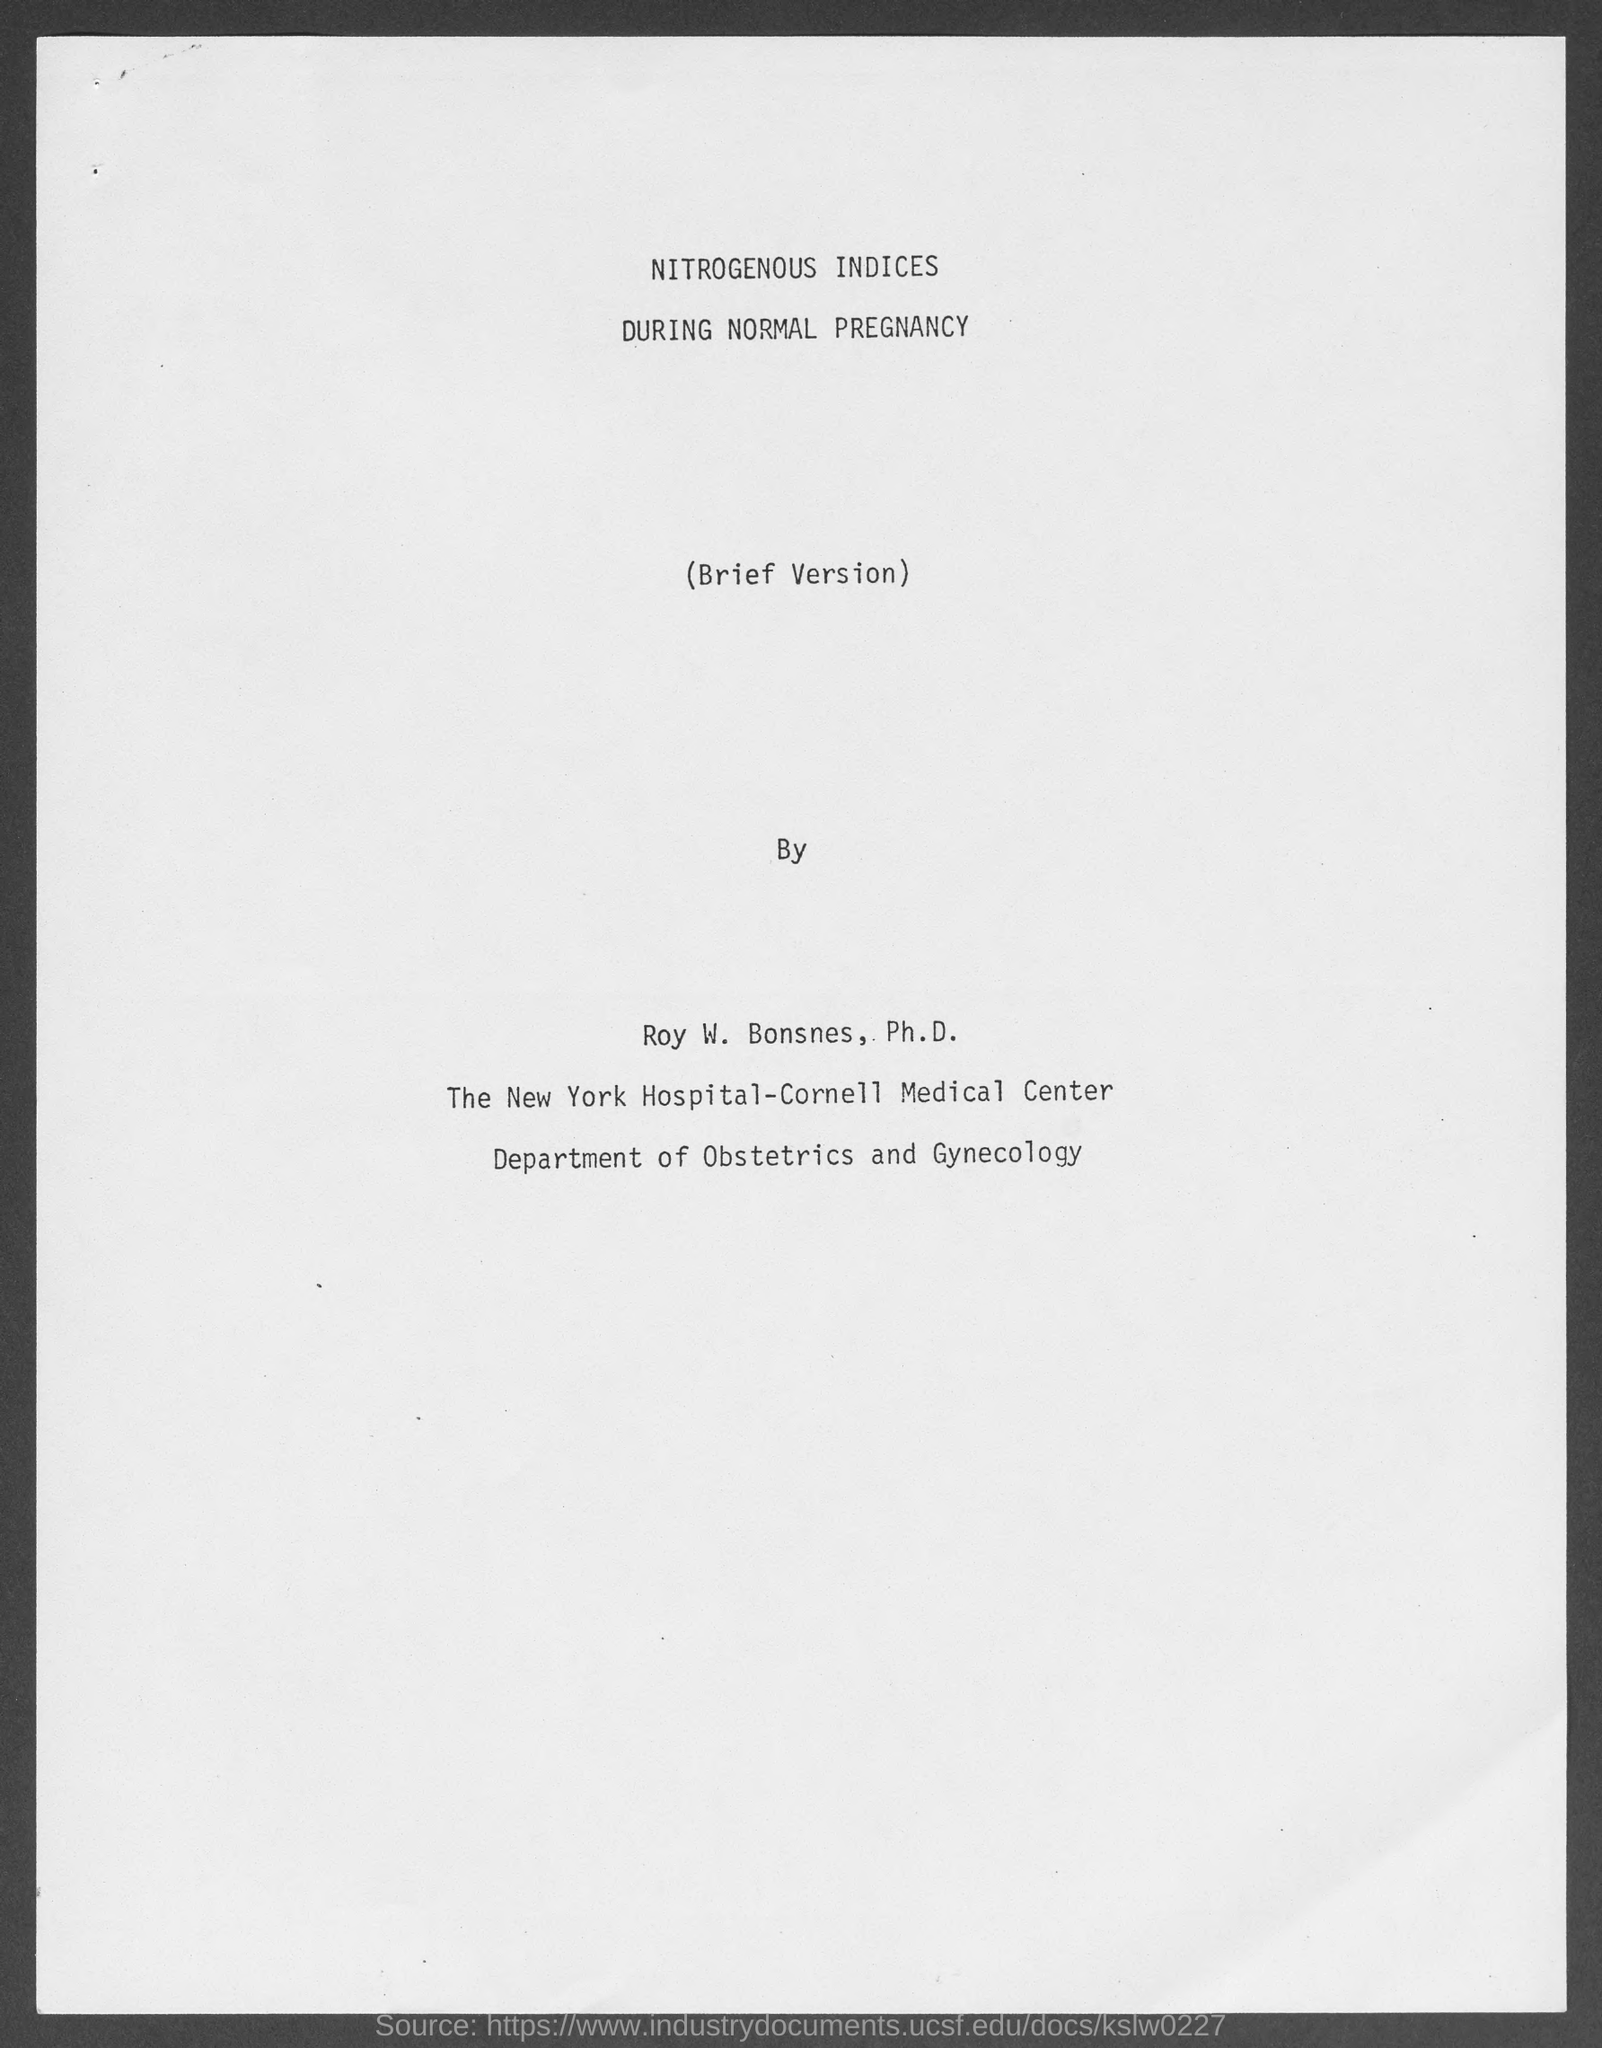Indicate a few pertinent items in this graphic. It is declared that Roy W. Bonses, Ph.D. belongs to the department of obstetrics and gynecology. 